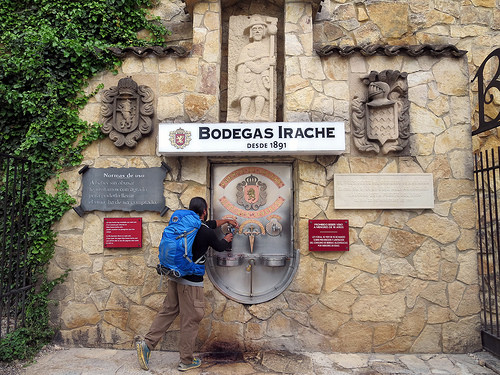<image>
Can you confirm if the sign is in front of the man? No. The sign is not in front of the man. The spatial positioning shows a different relationship between these objects. 